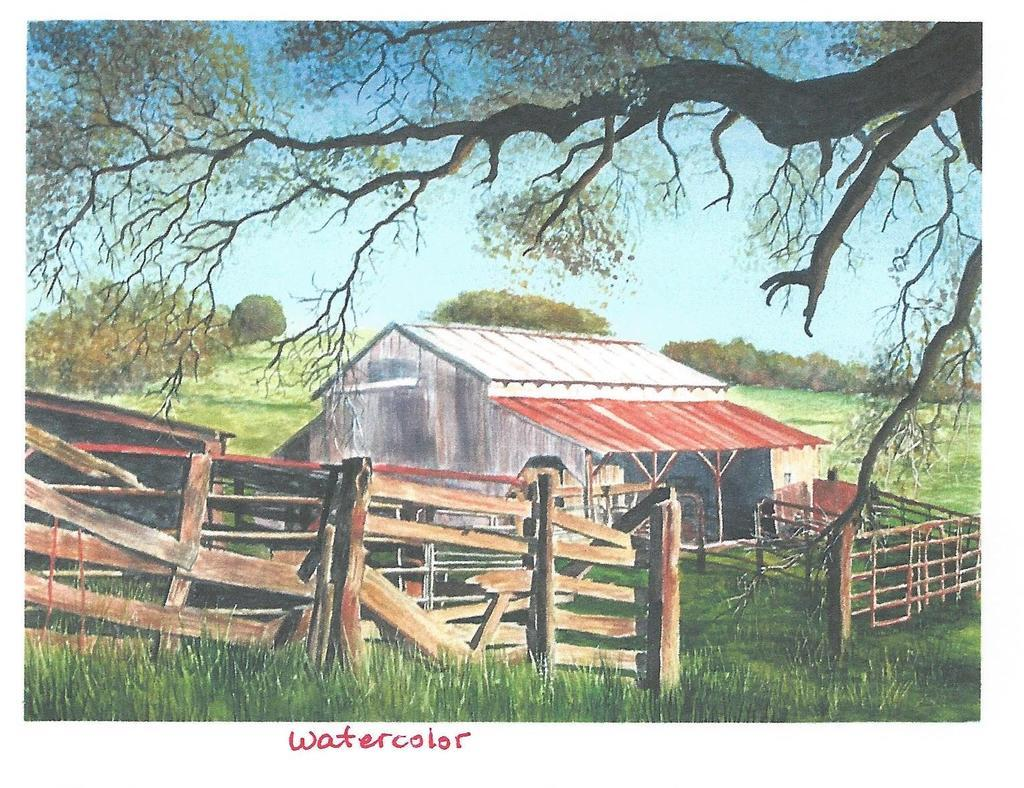<image>
Create a compact narrative representing the image presented. A cool water color picture of a farm 